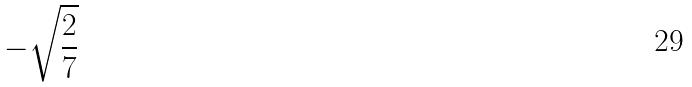<formula> <loc_0><loc_0><loc_500><loc_500>- \sqrt { \frac { 2 } { 7 } }</formula> 